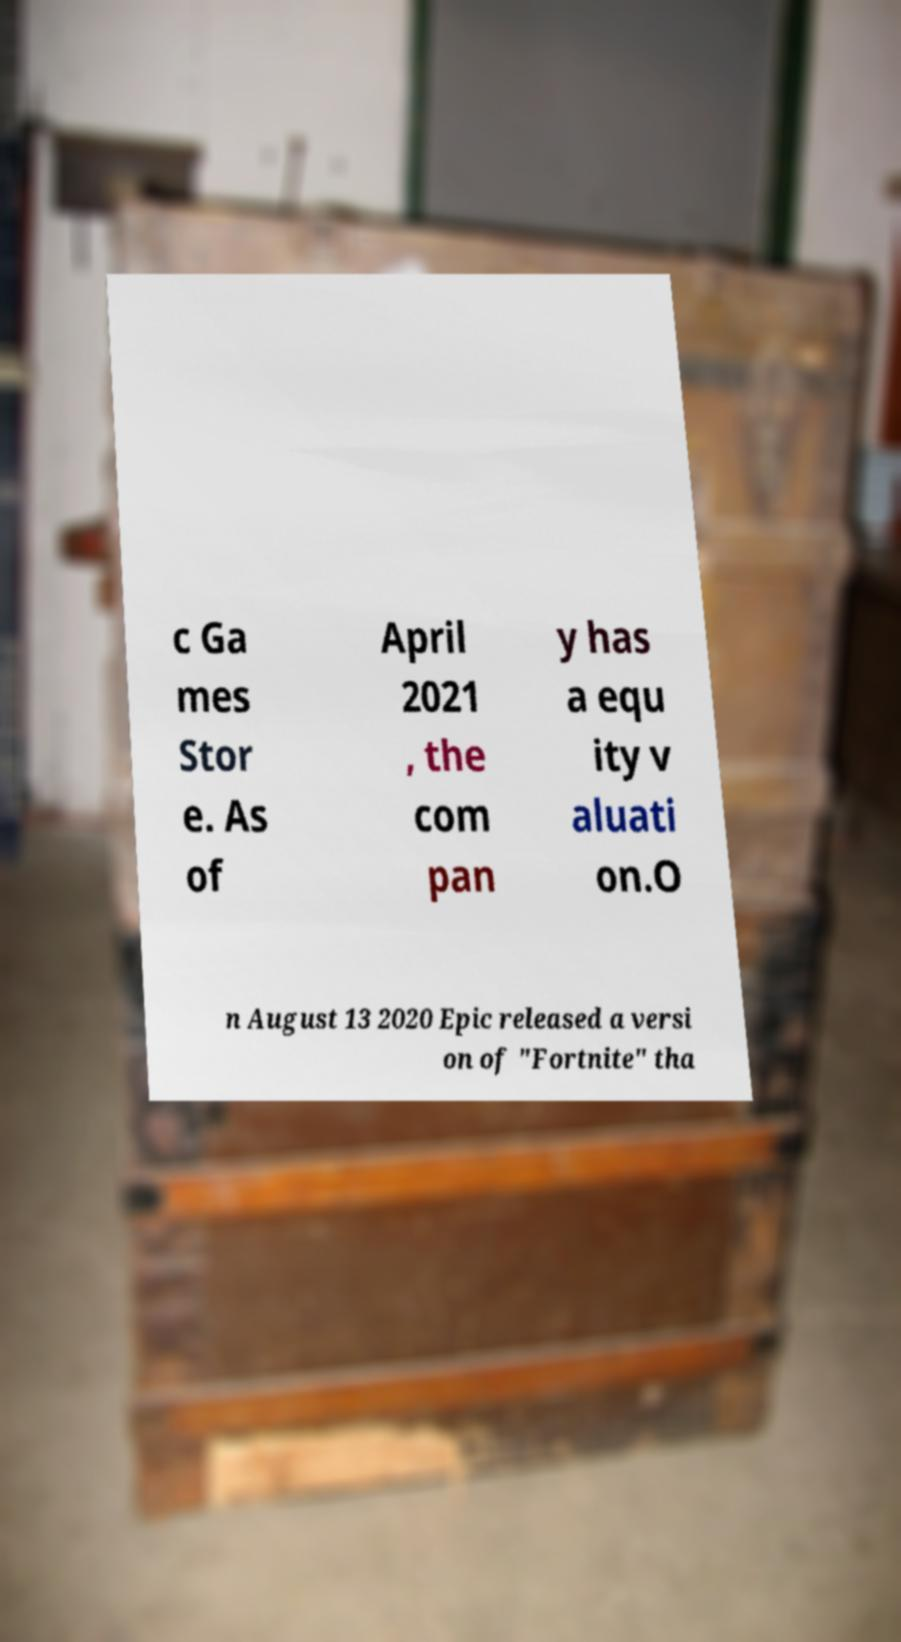What messages or text are displayed in this image? I need them in a readable, typed format. c Ga mes Stor e. As of April 2021 , the com pan y has a equ ity v aluati on.O n August 13 2020 Epic released a versi on of "Fortnite" tha 